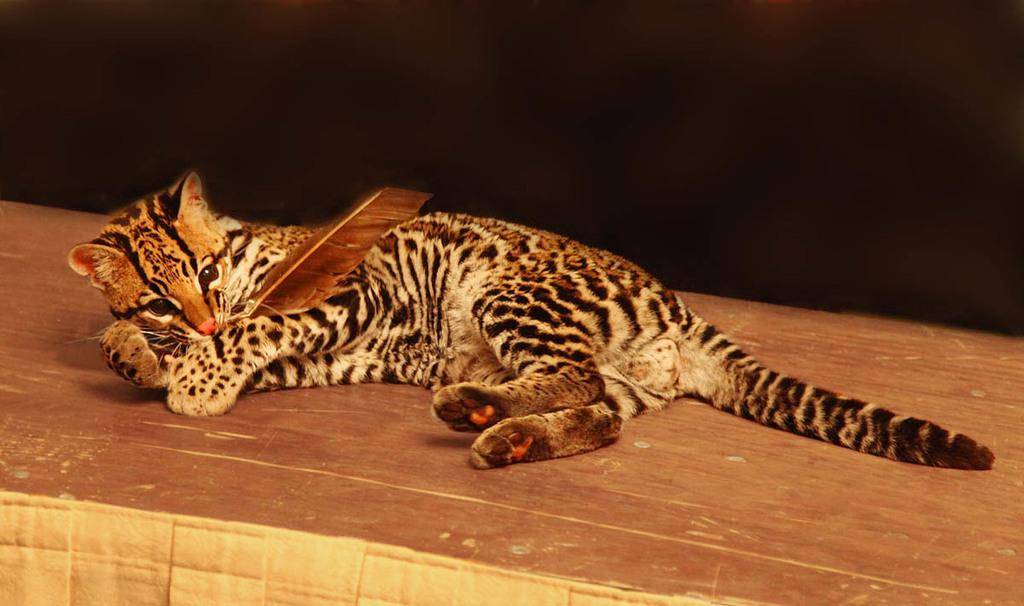What animal is present in the image? There is a cat in the image. What is the cat doing with its mouth? The cat is holding something with its mouth. Where is the cat located in the image? The cat is lying on a table. What is the color of the background in the image? The background of the image is black. What book is the cat reading in the image? There is no book or reading activity present in the image. 